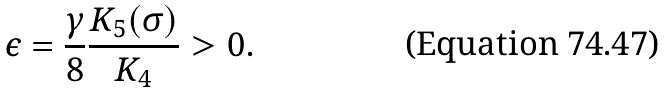Convert formula to latex. <formula><loc_0><loc_0><loc_500><loc_500>\epsilon = \frac { \gamma } { 8 } \frac { K _ { 5 } ( \sigma ) } { K _ { 4 } } > 0 .</formula> 